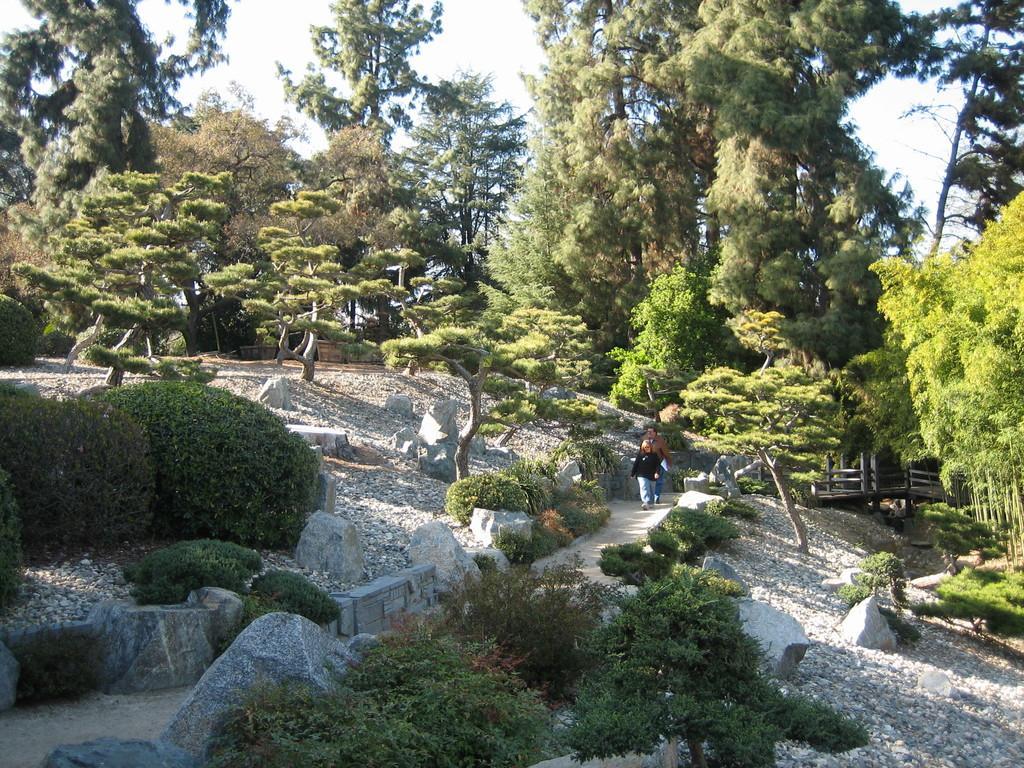Describe this image in one or two sentences. In the image we can see people wearing clothes and they are walking. Every there are trees, plants and stones. Here we can see a bridge and a white sky. 